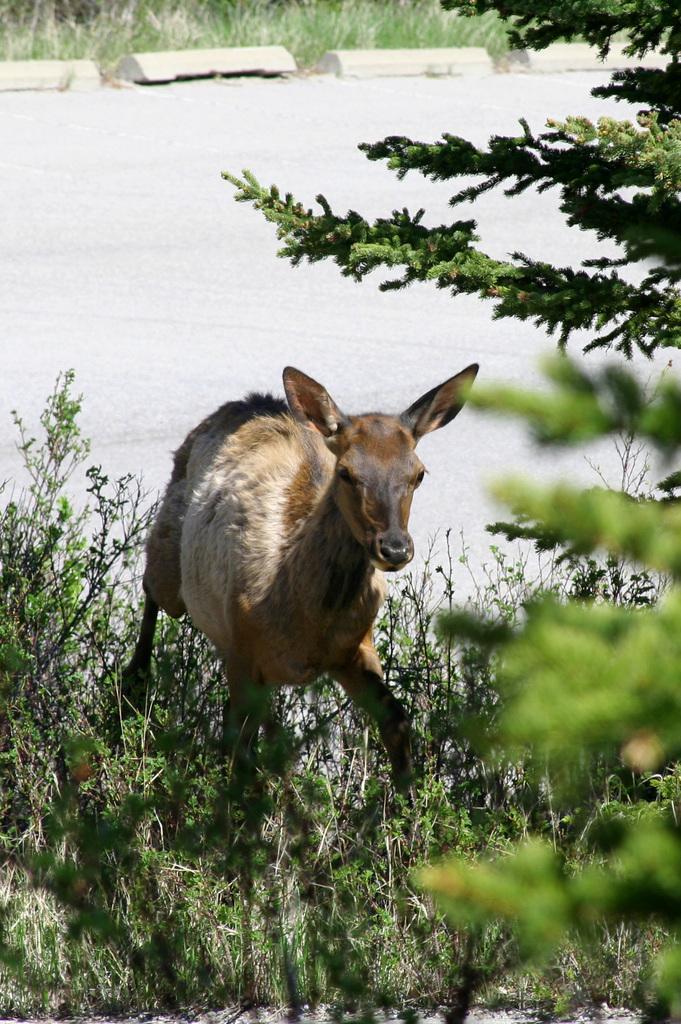In one or two sentences, can you explain what this image depicts? We can see water,plants and water,on the right side of the image we can see leaves. In the background we can see grass. 